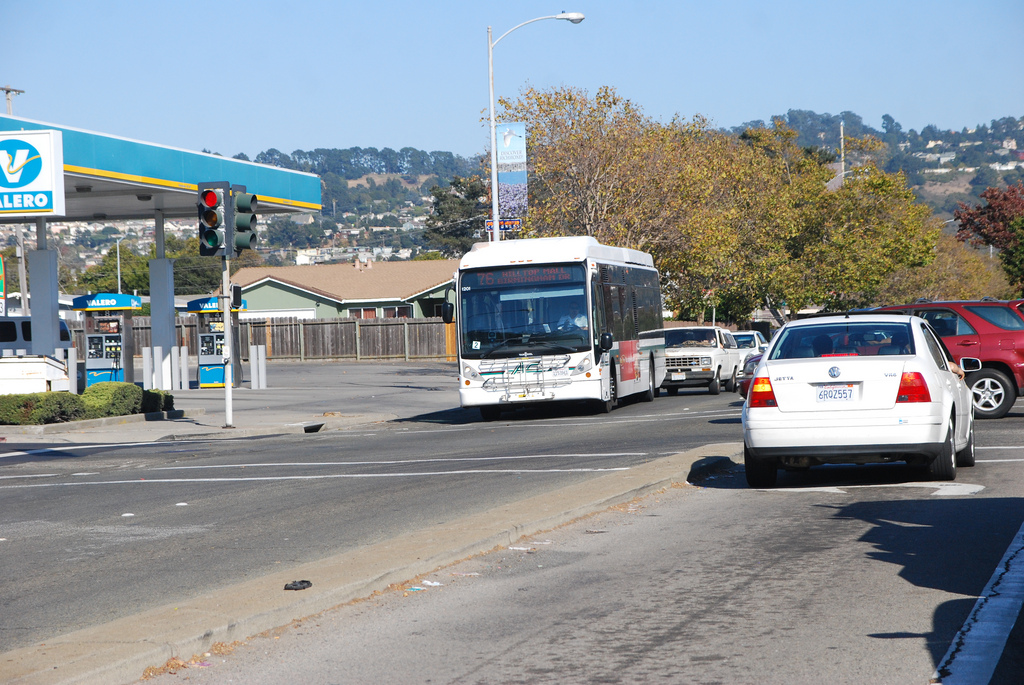Is the gas pump blue? While the gas pump is primarily white, it does feature blue branding elements from Valero, which may give the impression of being blue overall. 